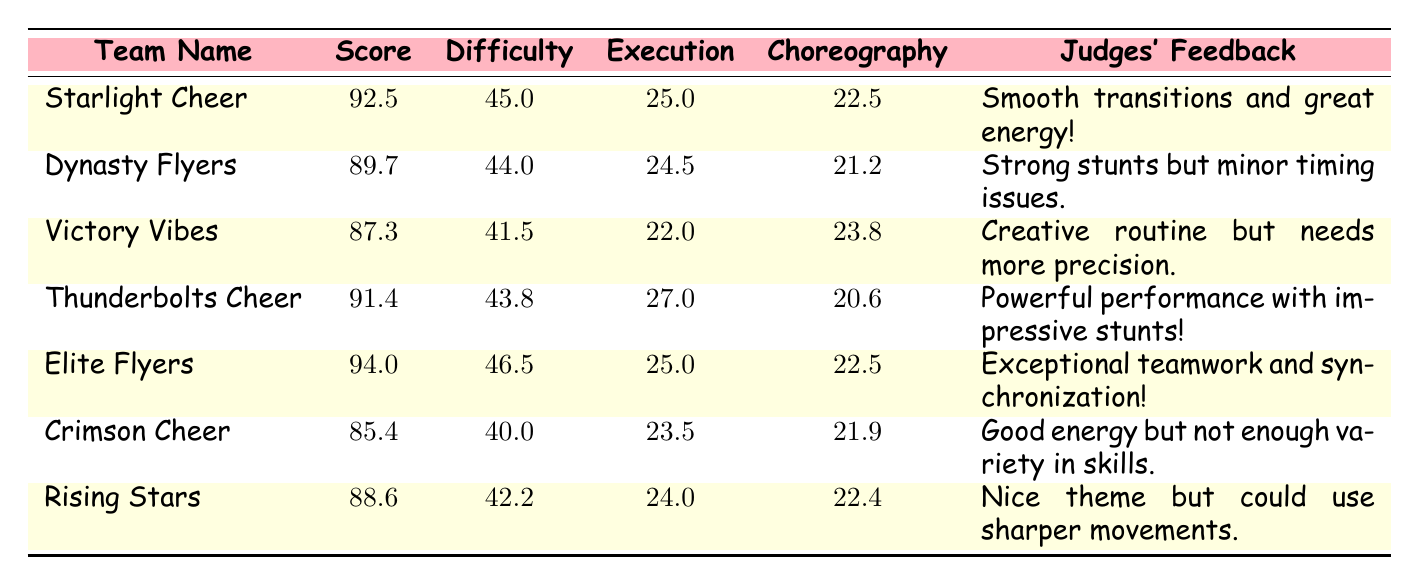What team has the highest score? The highest score in the table is found by comparing the score values of each team. The score for Elite Flyers is 94.0, which is higher than the scores of all other teams.
Answer: Elite Flyers What is the score of Thunderbolts Cheer? The table shows that Thunderbolts Cheer has a score of 91.4, which is directly listed under their name in the score column.
Answer: 91.4 Which team received feedback for having "good energy"? The feedback for Crimson Cheer states "Good energy but not enough variety in skills," indicating that this team received the specified feedback.
Answer: Crimson Cheer What is the difference in scores between Elite Flyers and Victory Vibes? The score for Elite Flyers is 94.0 and for Victory Vibes is 87.3. The difference is calculated as 94.0 - 87.3 = 6.7.
Answer: 6.7 Did any team score below 86? By examining the scores listed in the table, only Crimson Cheer scored 85.4, which is below 86. Therefore, the answer is yes.
Answer: Yes What is the average execution score of all teams? To find the average execution score, first sum all execution scores: (25.0 + 24.5 + 22.0 + 27.0 + 25.0 + 23.5 + 24.0) = 171.0. There are 7 teams, so the average is 171.0 / 7 ≈ 24.4.
Answer: 24.4 Which teams received feedback that mentioned precision? Looking at the feedback, Victory Vibes received feedback about needing more precision. Rising Stars also mentioned needing sharper movements, indicating both teams had related feedback.
Answer: Victory Vibes, Rising Stars How many points higher is the difficulty score of Elite Flyers compared to that of Crimson Cheer? The difficulty score for Elite Flyers is 46.5, and for Crimson Cheer, it is 40.0. Subtracting these values gives 46.5 - 40.0 = 6.5.
Answer: 6.5 Which team has the second high score and what is the feedback for them? The second-highest score is for Thunderbolts Cheer at 91.4, and their feedback reads "Powerful performance with impressive stunts!"
Answer: Thunderbolts Cheer; Powerful performance with impressive stunts! What is the total score of all teams combined? To find the total score, sum all the scores: 92.5 + 89.7 + 87.3 + 91.4 + 94.0 + 85.4 + 88.6 = 519.9.
Answer: 519.9 